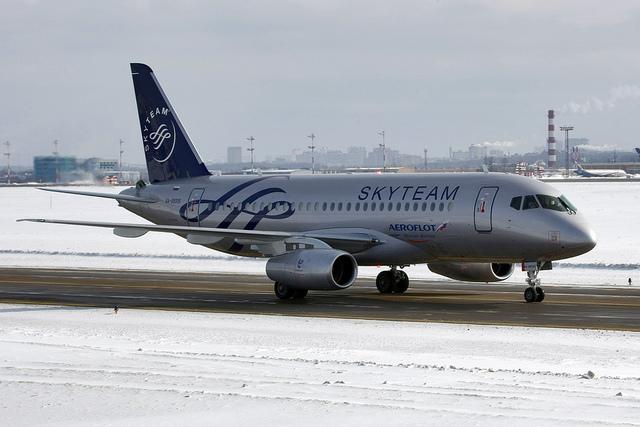Is there snow on the ground?
Concise answer only. Yes. What airline owns the plane?
Quick response, please. Skyteam. How many windows are on the plane?
Give a very brief answer. 35. 